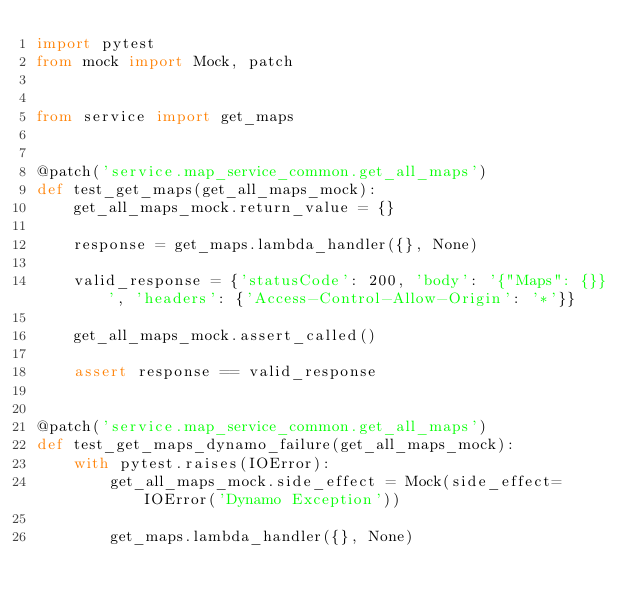<code> <loc_0><loc_0><loc_500><loc_500><_Python_>import pytest
from mock import Mock, patch


from service import get_maps


@patch('service.map_service_common.get_all_maps')
def test_get_maps(get_all_maps_mock):
    get_all_maps_mock.return_value = {}

    response = get_maps.lambda_handler({}, None)

    valid_response = {'statusCode': 200, 'body': '{"Maps": {}}', 'headers': {'Access-Control-Allow-Origin': '*'}}

    get_all_maps_mock.assert_called()

    assert response == valid_response


@patch('service.map_service_common.get_all_maps')
def test_get_maps_dynamo_failure(get_all_maps_mock):
    with pytest.raises(IOError):
        get_all_maps_mock.side_effect = Mock(side_effect=IOError('Dynamo Exception'))

        get_maps.lambda_handler({}, None)
</code> 